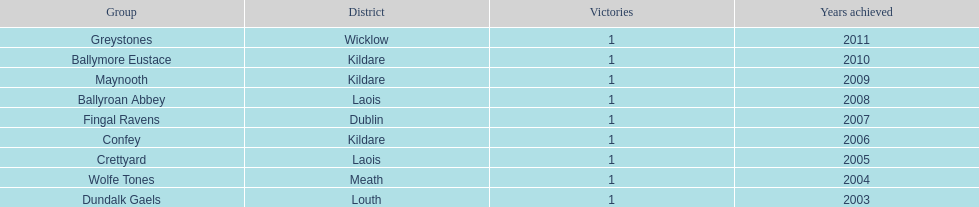Which team won after ballymore eustace? Greystones. 